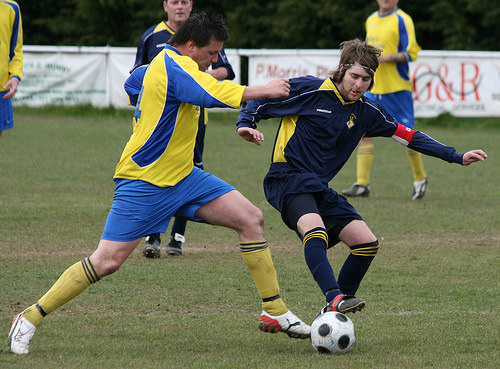<image>
Is the shoe behind the ball? Yes. From this viewpoint, the shoe is positioned behind the ball, with the ball partially or fully occluding the shoe. 